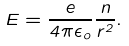Convert formula to latex. <formula><loc_0><loc_0><loc_500><loc_500>E = \frac { e } { 4 \pi \epsilon _ { o } } \frac { n } { r ^ { 2 } } .</formula> 